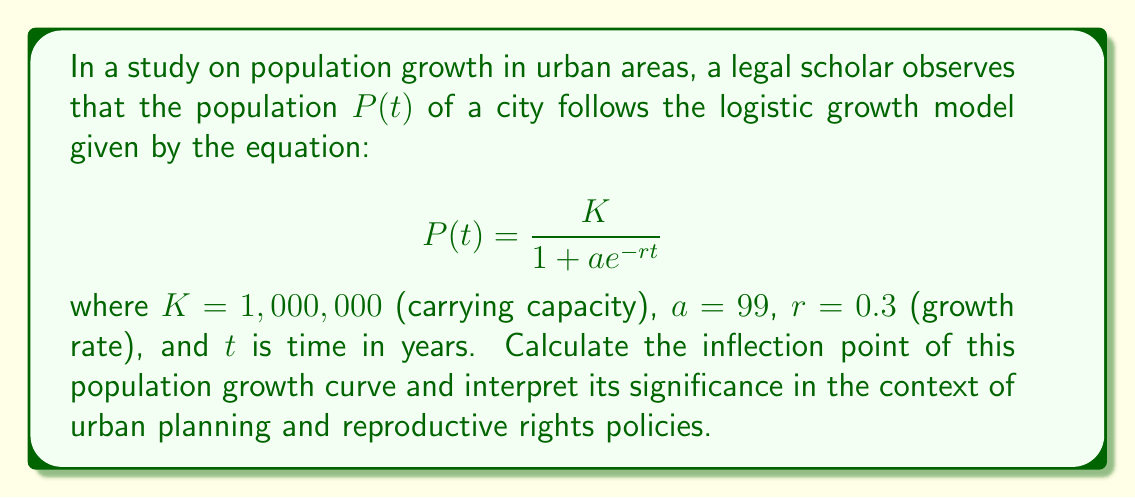What is the answer to this math problem? To find the inflection point of the logistic growth curve, we need to follow these steps:

1) The inflection point occurs at the time $t$ when the population is half of the carrying capacity. In this case, $P(t) = K/2 = 500,000$.

2) We can set up the equation:

   $$500,000 = \frac{1,000,000}{1 + 99e^{-0.3t}}$$

3) Simplify:
   $$\frac{1}{2} = \frac{1}{1 + 99e^{-0.3t}}$$

4) Take the reciprocal of both sides:
   $$2 = 1 + 99e^{-0.3t}$$

5) Subtract 1 from both sides:
   $$1 = 99e^{-0.3t}$$

6) Take the natural log of both sides:
   $$\ln(1) = \ln(99) - 0.3t$$

7) Solve for $t$:
   $$0 = 4.5951 - 0.3t$$
   $$0.3t = 4.5951$$
   $$t = 15.3170$$

8) Therefore, the inflection point occurs at approximately 15.32 years.

Interpretation: The inflection point represents the time when the population growth rate is at its maximum. Before this point, growth accelerates; after this point, growth decelerates. In the context of urban planning and reproductive rights policies, this inflection point is crucial. It indicates when the demand for resources and services (including reproductive health services) will be increasing most rapidly, allowing policymakers to anticipate and plan for this peak in demand growth.
Answer: 15.32 years 